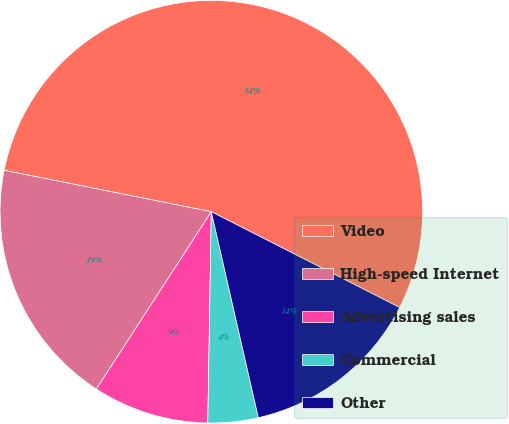Convert chart to OTSL. <chart><loc_0><loc_0><loc_500><loc_500><pie_chart><fcel>Video<fcel>High-speed Internet<fcel>Advertising sales<fcel>Commercial<fcel>Other<nl><fcel>54.35%<fcel>18.99%<fcel>8.89%<fcel>3.84%<fcel>13.94%<nl></chart> 